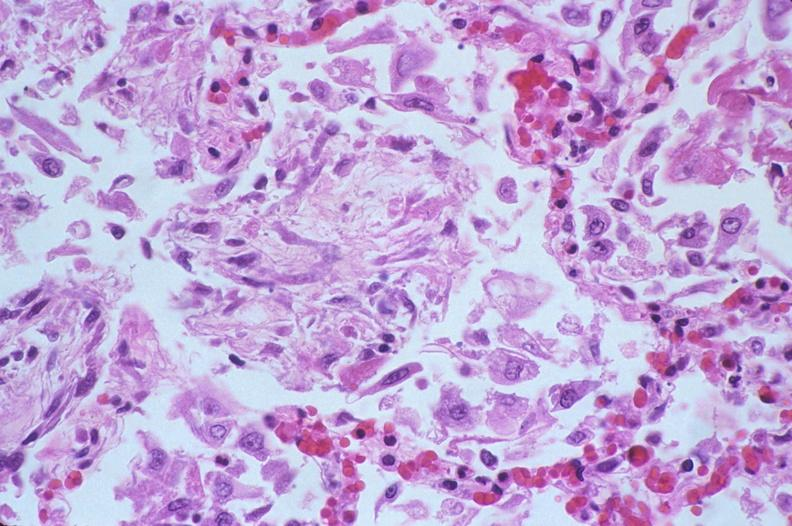does nodular tumor show lung, diffuse alveolar damage?
Answer the question using a single word or phrase. No 